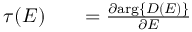<formula> <loc_0><loc_0><loc_500><loc_500>\begin{array} { r l r } { \tau ( E ) } & { = \frac { \partial \arg \{ D ( E ) \} } { \partial E } } \end{array}</formula> 